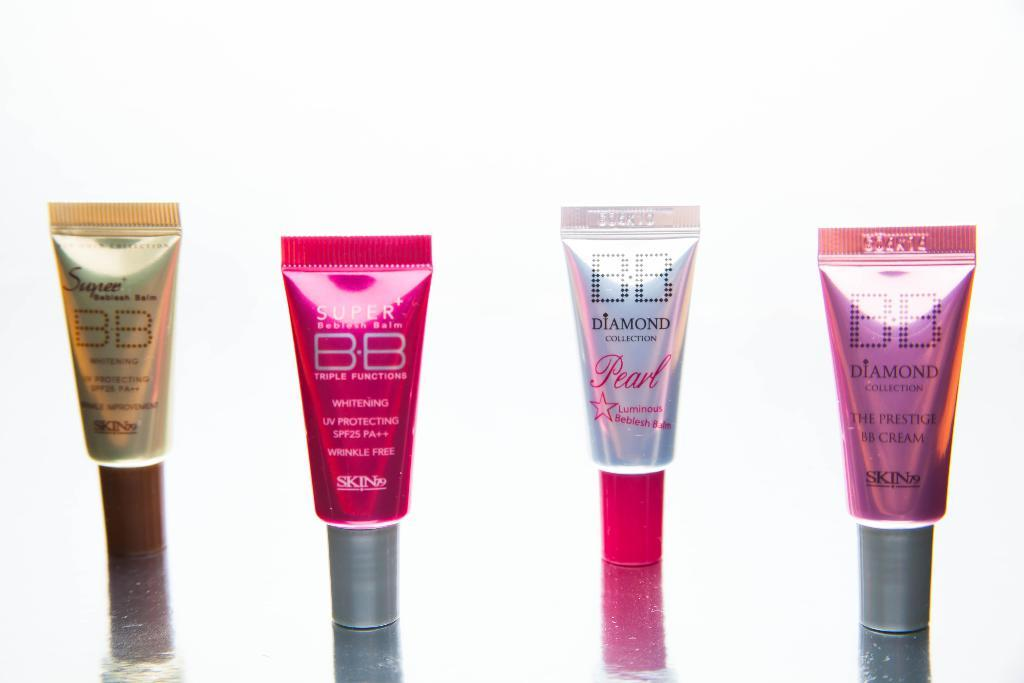<image>
Provide a brief description of the given image. Four small tubes of BB brand cream with two labeled super and the other two labeled diamond collection. 